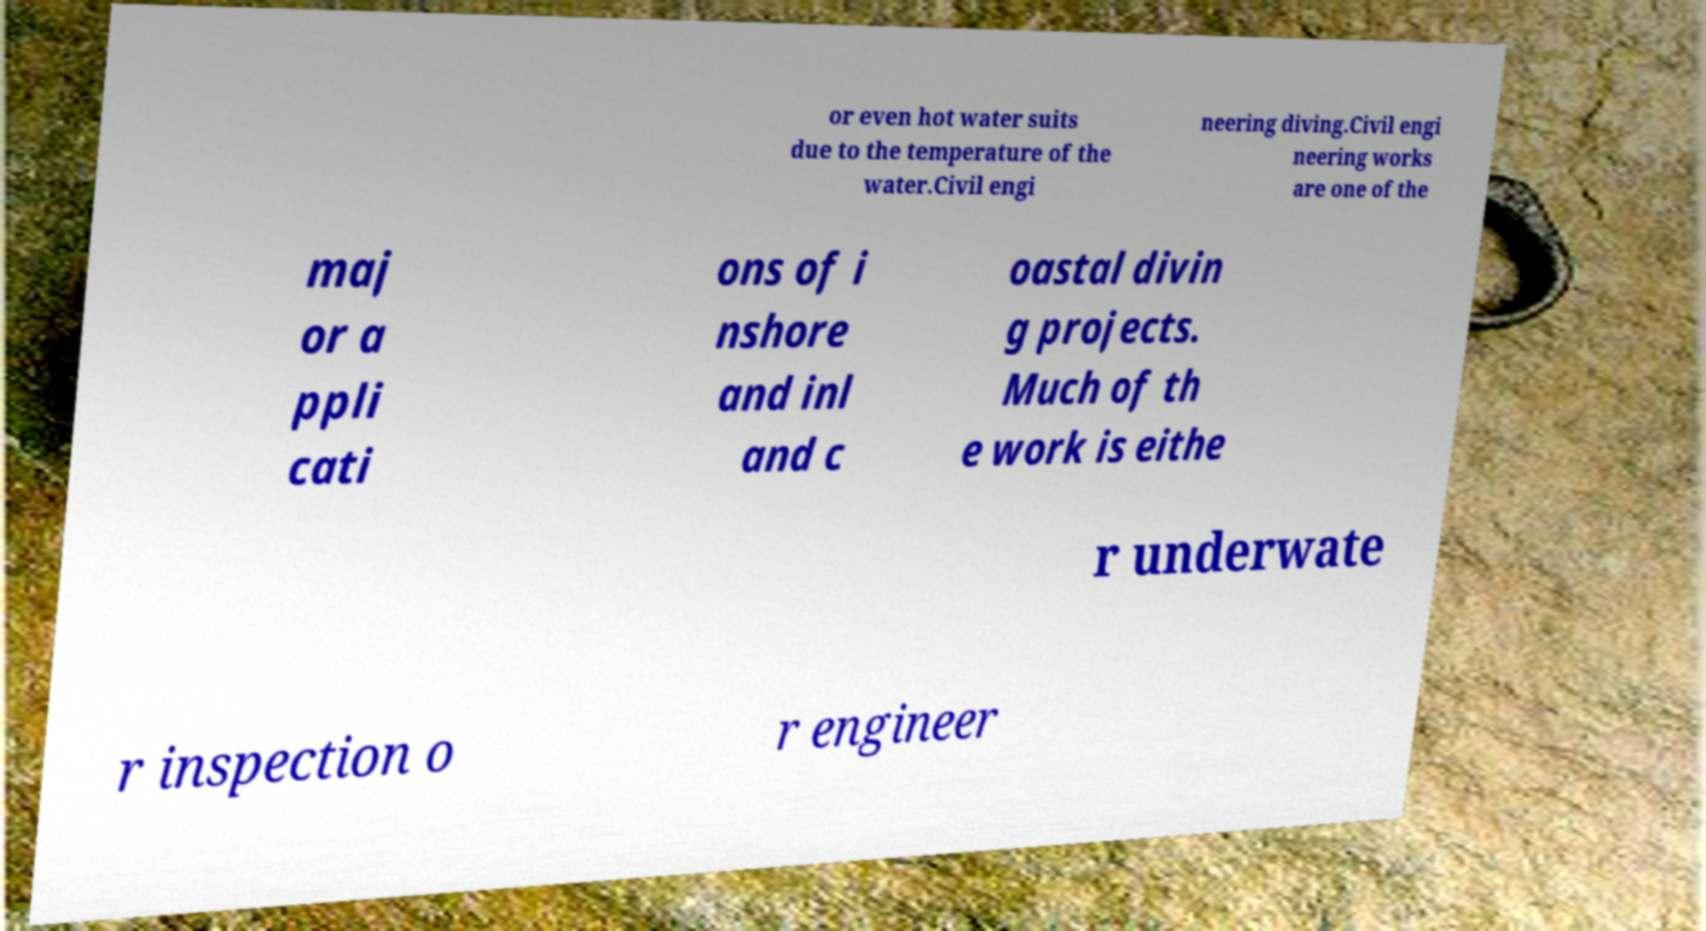Could you assist in decoding the text presented in this image and type it out clearly? or even hot water suits due to the temperature of the water.Civil engi neering diving.Civil engi neering works are one of the maj or a ppli cati ons of i nshore and inl and c oastal divin g projects. Much of th e work is eithe r underwate r inspection o r engineer 